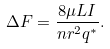<formula> <loc_0><loc_0><loc_500><loc_500>\Delta F = { \frac { 8 \mu L I } { n r ^ { 2 } q ^ { * } } } .</formula> 